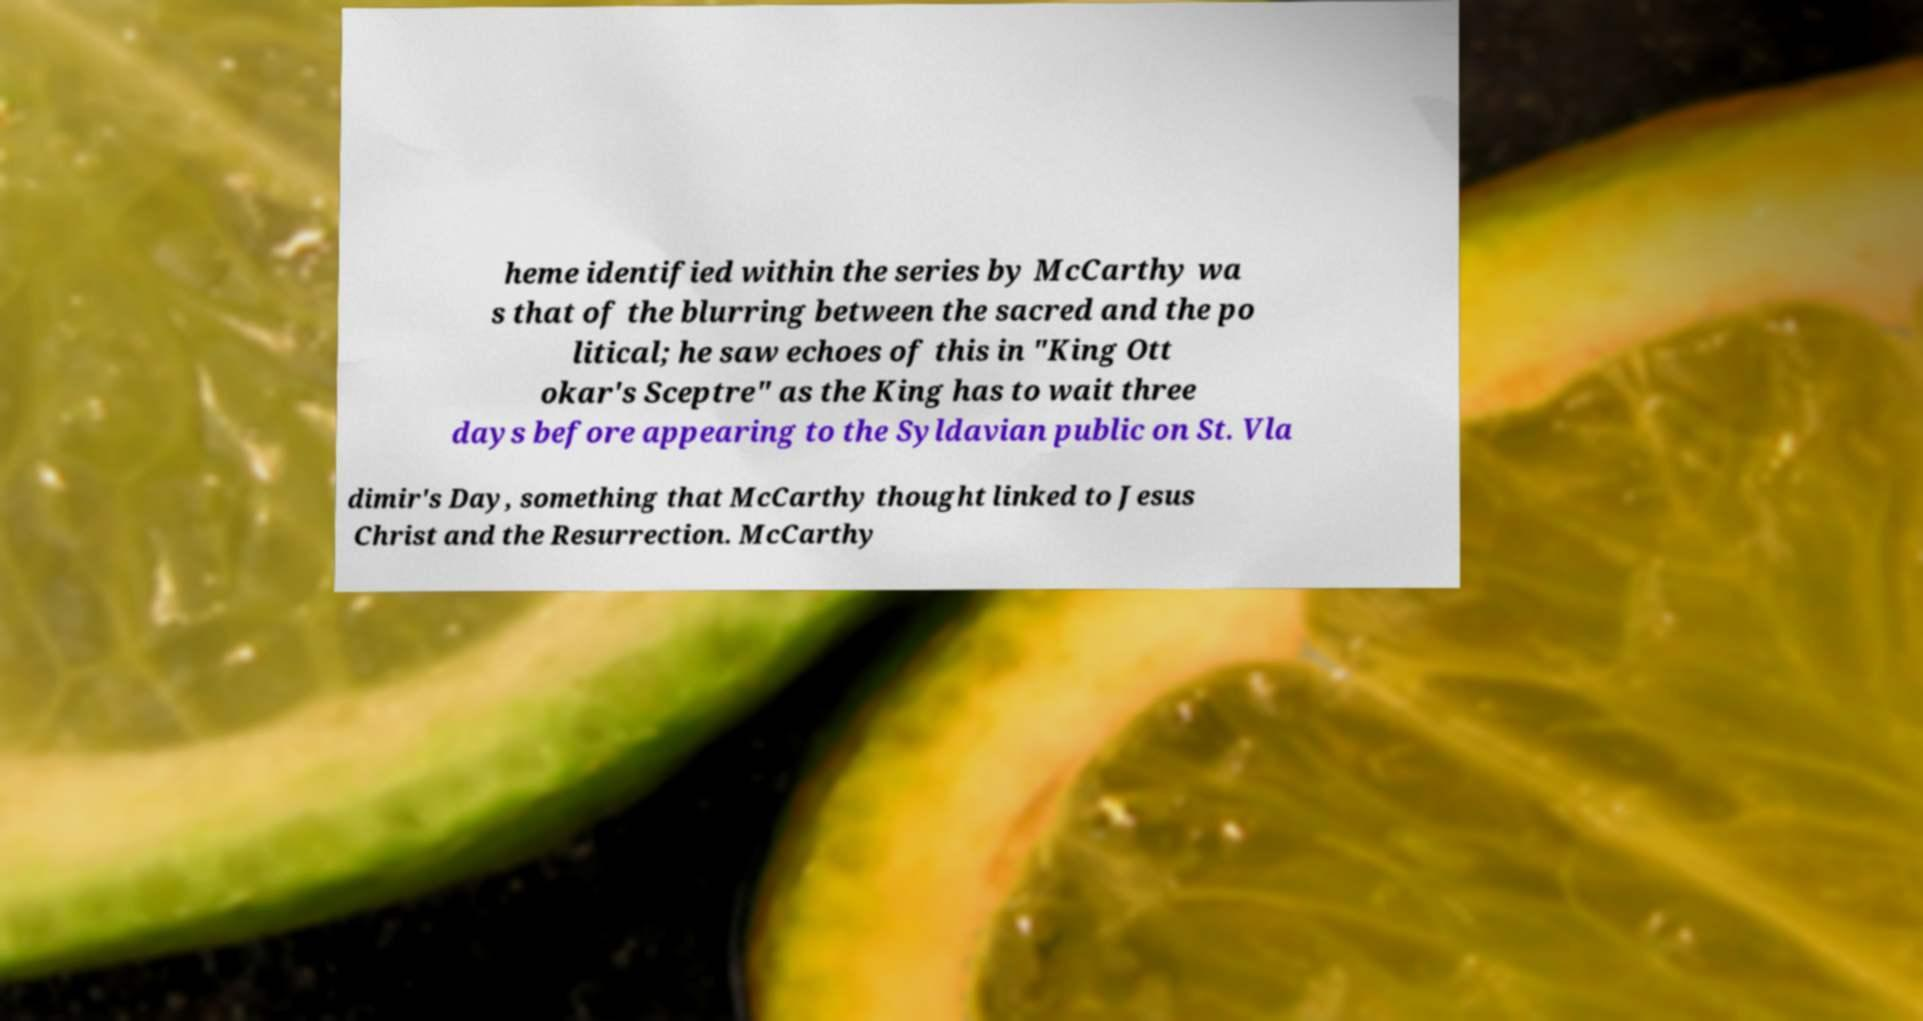There's text embedded in this image that I need extracted. Can you transcribe it verbatim? heme identified within the series by McCarthy wa s that of the blurring between the sacred and the po litical; he saw echoes of this in "King Ott okar's Sceptre" as the King has to wait three days before appearing to the Syldavian public on St. Vla dimir's Day, something that McCarthy thought linked to Jesus Christ and the Resurrection. McCarthy 